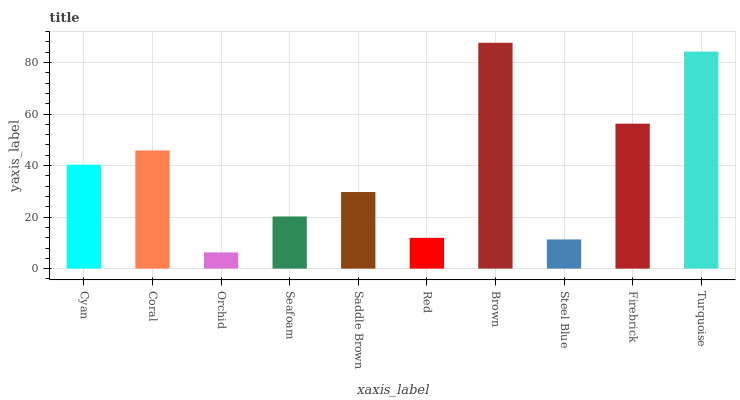Is Orchid the minimum?
Answer yes or no. Yes. Is Brown the maximum?
Answer yes or no. Yes. Is Coral the minimum?
Answer yes or no. No. Is Coral the maximum?
Answer yes or no. No. Is Coral greater than Cyan?
Answer yes or no. Yes. Is Cyan less than Coral?
Answer yes or no. Yes. Is Cyan greater than Coral?
Answer yes or no. No. Is Coral less than Cyan?
Answer yes or no. No. Is Cyan the high median?
Answer yes or no. Yes. Is Saddle Brown the low median?
Answer yes or no. Yes. Is Seafoam the high median?
Answer yes or no. No. Is Brown the low median?
Answer yes or no. No. 